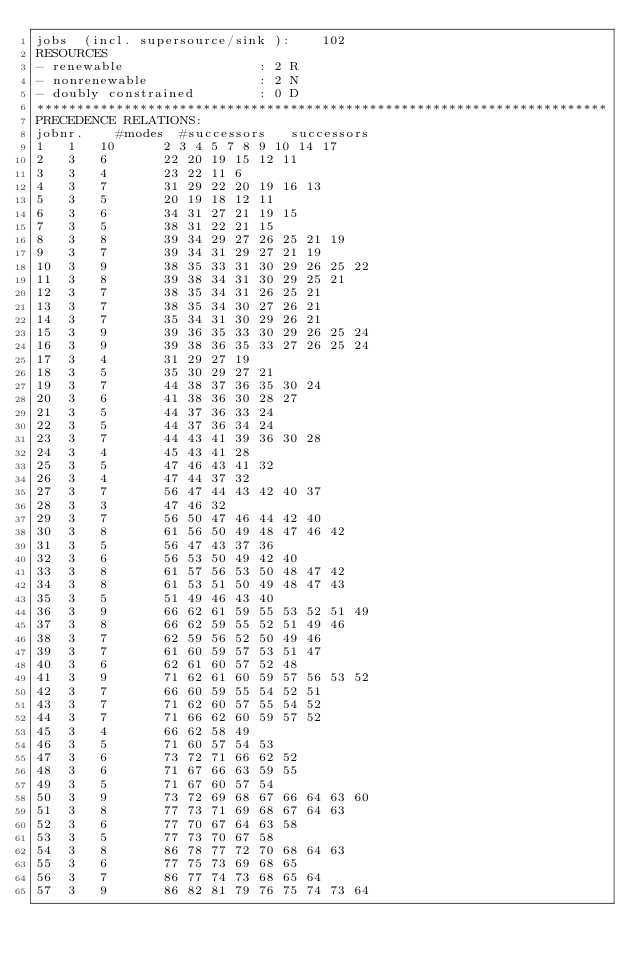<code> <loc_0><loc_0><loc_500><loc_500><_ObjectiveC_>jobs  (incl. supersource/sink ):	102
RESOURCES
- renewable                 : 2 R
- nonrenewable              : 2 N
- doubly constrained        : 0 D
************************************************************************
PRECEDENCE RELATIONS:
jobnr.    #modes  #successors   successors
1	1	10		2 3 4 5 7 8 9 10 14 17 
2	3	6		22 20 19 15 12 11 
3	3	4		23 22 11 6 
4	3	7		31 29 22 20 19 16 13 
5	3	5		20 19 18 12 11 
6	3	6		34 31 27 21 19 15 
7	3	5		38 31 22 21 15 
8	3	8		39 34 29 27 26 25 21 19 
9	3	7		39 34 31 29 27 21 19 
10	3	9		38 35 33 31 30 29 26 25 22 
11	3	8		39 38 34 31 30 29 25 21 
12	3	7		38 35 34 31 26 25 21 
13	3	7		38 35 34 30 27 26 21 
14	3	7		35 34 31 30 29 26 21 
15	3	9		39 36 35 33 30 29 26 25 24 
16	3	9		39 38 36 35 33 27 26 25 24 
17	3	4		31 29 27 19 
18	3	5		35 30 29 27 21 
19	3	7		44 38 37 36 35 30 24 
20	3	6		41 38 36 30 28 27 
21	3	5		44 37 36 33 24 
22	3	5		44 37 36 34 24 
23	3	7		44 43 41 39 36 30 28 
24	3	4		45 43 41 28 
25	3	5		47 46 43 41 32 
26	3	4		47 44 37 32 
27	3	7		56 47 44 43 42 40 37 
28	3	3		47 46 32 
29	3	7		56 50 47 46 44 42 40 
30	3	8		61 56 50 49 48 47 46 42 
31	3	5		56 47 43 37 36 
32	3	6		56 53 50 49 42 40 
33	3	8		61 57 56 53 50 48 47 42 
34	3	8		61 53 51 50 49 48 47 43 
35	3	5		51 49 46 43 40 
36	3	9		66 62 61 59 55 53 52 51 49 
37	3	8		66 62 59 55 52 51 49 46 
38	3	7		62 59 56 52 50 49 46 
39	3	7		61 60 59 57 53 51 47 
40	3	6		62 61 60 57 52 48 
41	3	9		71 62 61 60 59 57 56 53 52 
42	3	7		66 60 59 55 54 52 51 
43	3	7		71 62 60 57 55 54 52 
44	3	7		71 66 62 60 59 57 52 
45	3	4		66 62 58 49 
46	3	5		71 60 57 54 53 
47	3	6		73 72 71 66 62 52 
48	3	6		71 67 66 63 59 55 
49	3	5		71 67 60 57 54 
50	3	9		73 72 69 68 67 66 64 63 60 
51	3	8		77 73 71 69 68 67 64 63 
52	3	6		77 70 67 64 63 58 
53	3	5		77 73 70 67 58 
54	3	8		86 78 77 72 70 68 64 63 
55	3	6		77 75 73 69 68 65 
56	3	7		86 77 74 73 68 65 64 
57	3	9		86 82 81 79 76 75 74 73 64 </code> 